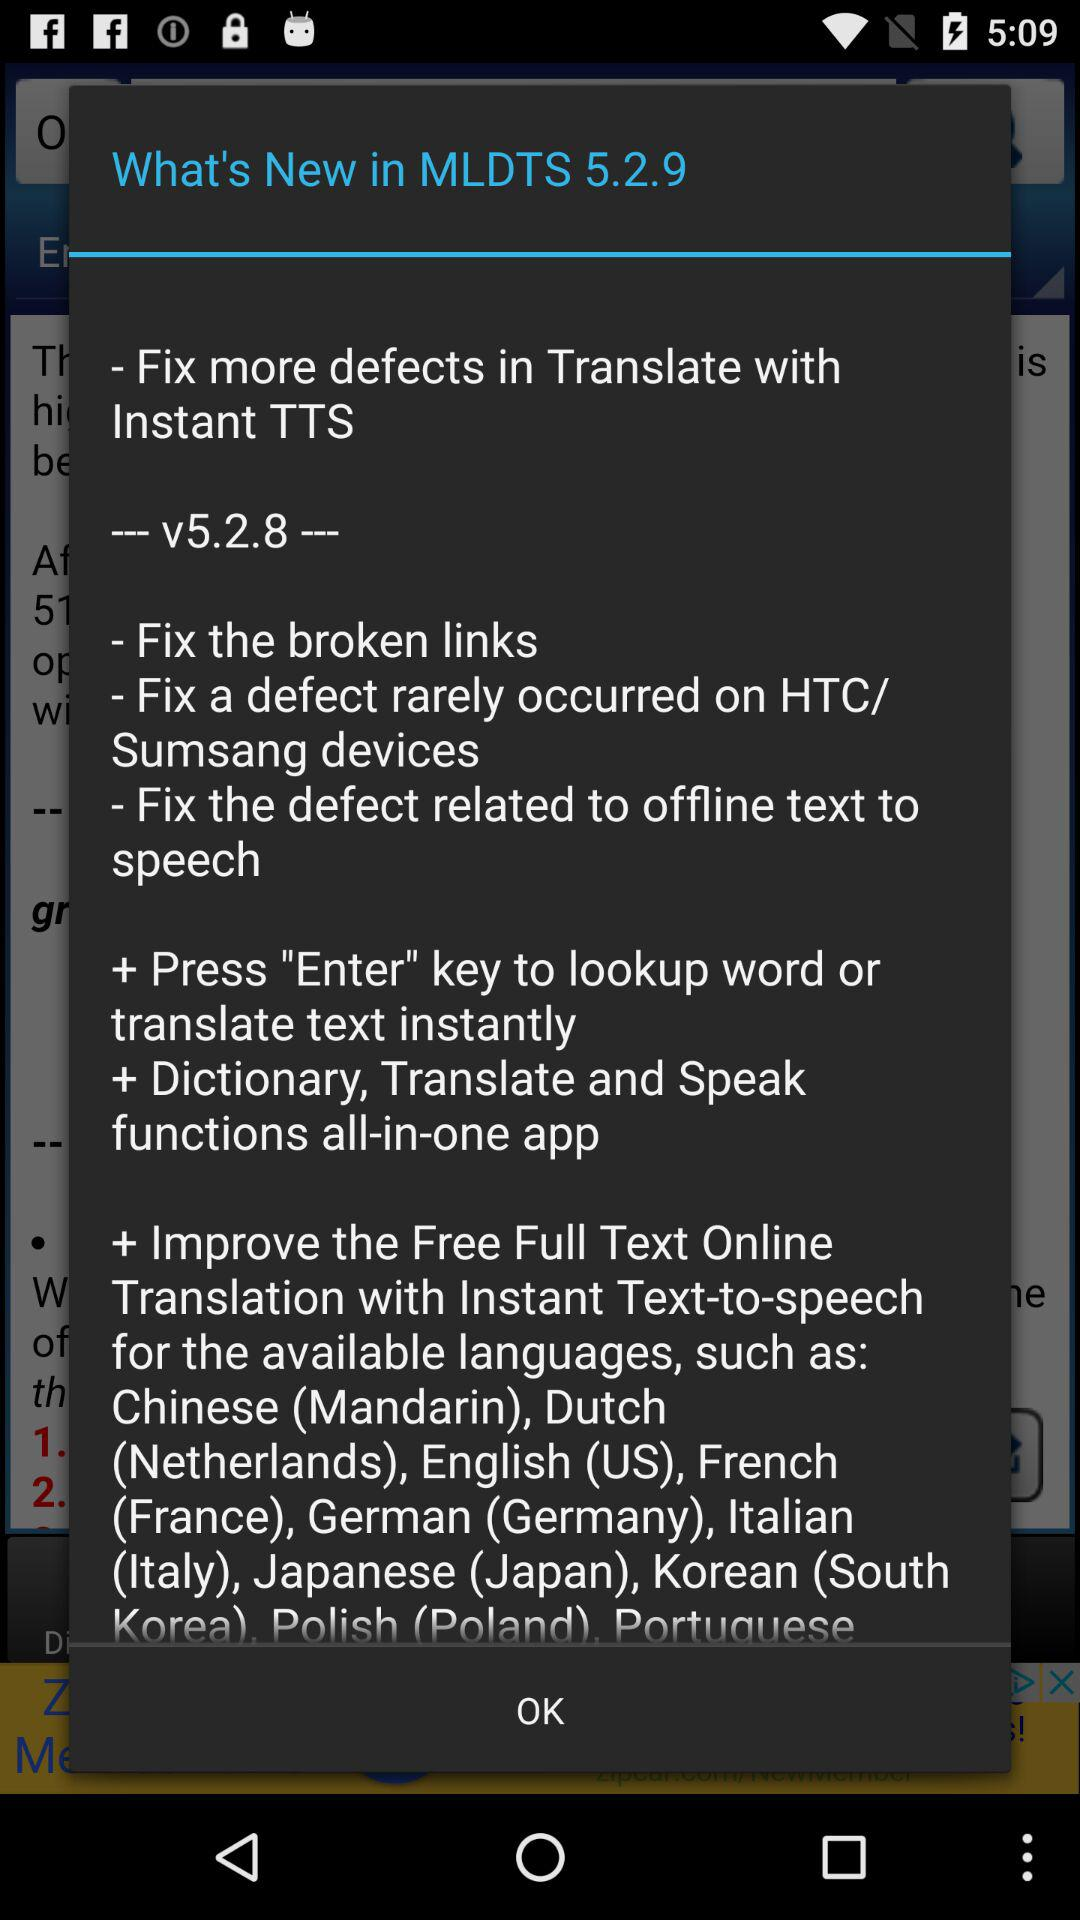What is the version of the application? The versions of the application are 5.2.9 and v5.2.8. 